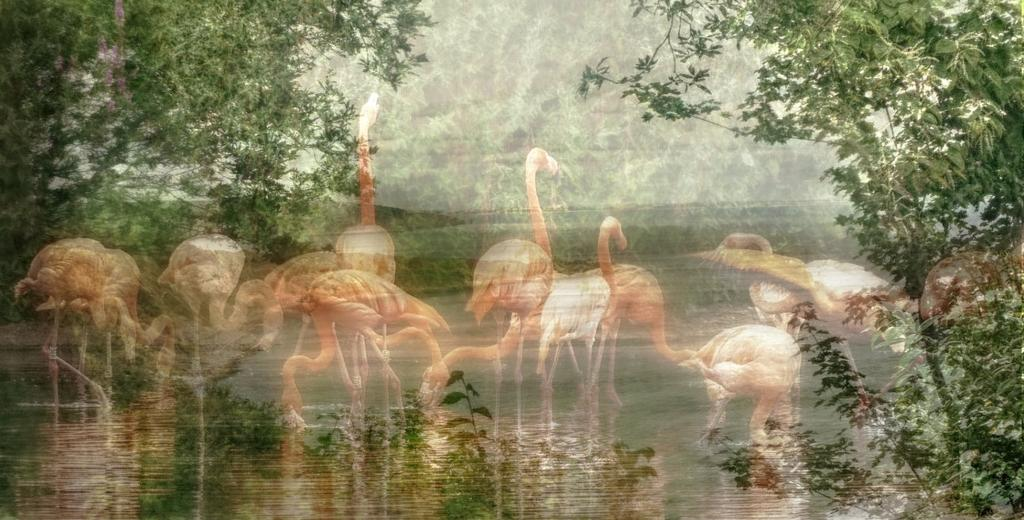What type of animals can be seen in the image? Birds can be seen in the water in the image. What can be seen in the background of the image? There are trees visible in the image. Can you describe any other objects or features in the image? There are other unspecified objects in the image. How many hydrants are visible in the image? There are no hydrants present in the image. What is the fifth object in the image? The provided facts do not specify a fifth object in the image. 